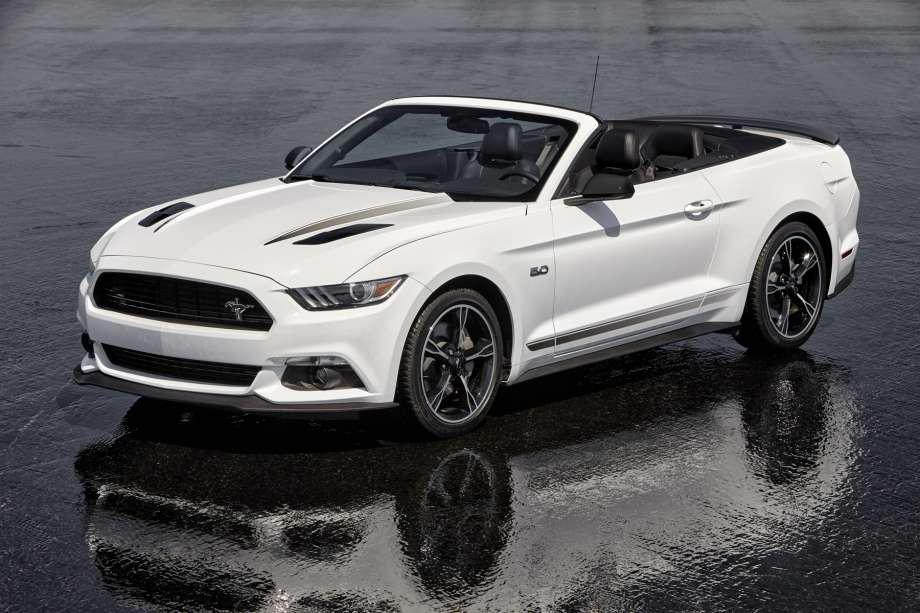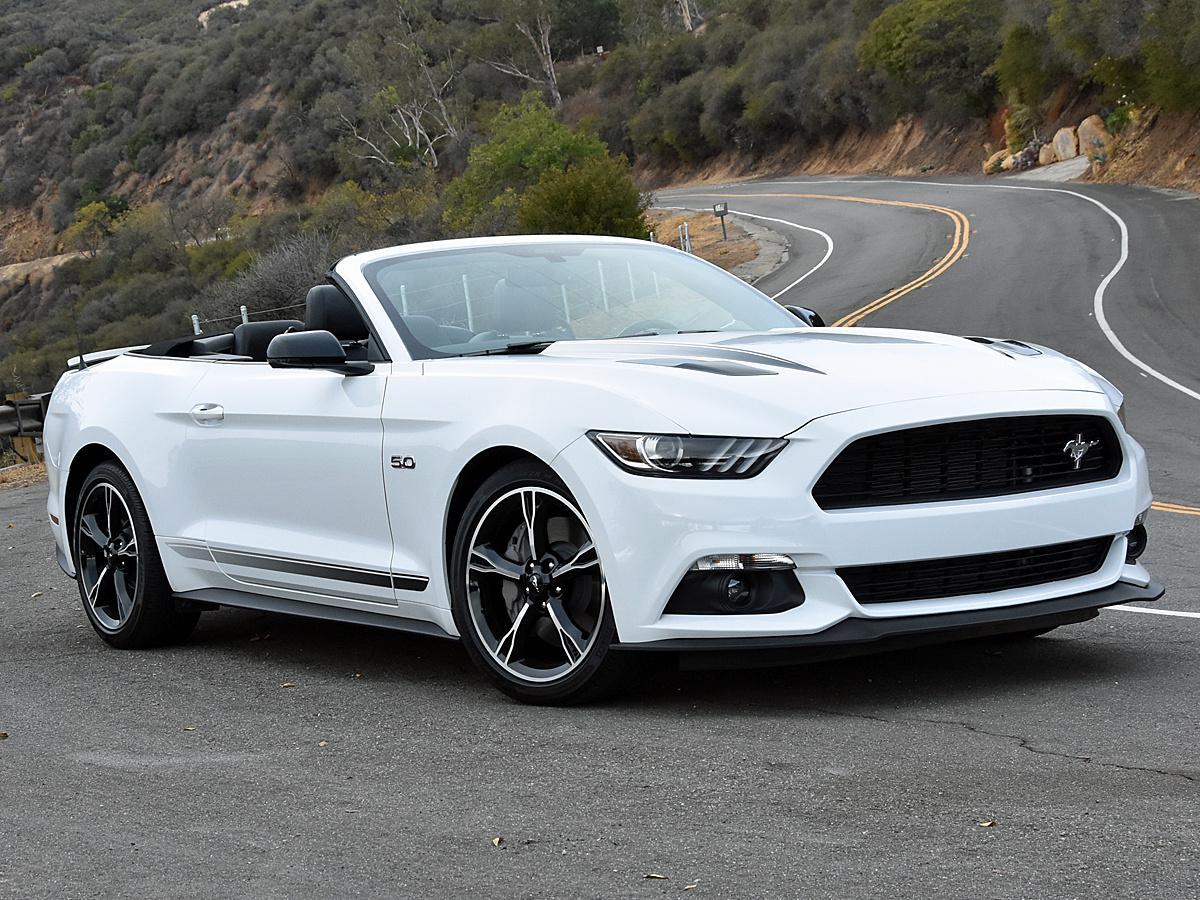The first image is the image on the left, the second image is the image on the right. Analyze the images presented: Is the assertion "One Ford Mustang is parked in dirt." valid? Answer yes or no. No. The first image is the image on the left, the second image is the image on the right. Considering the images on both sides, is "a convertible mustang is parked on a sandy beach" valid? Answer yes or no. No. 